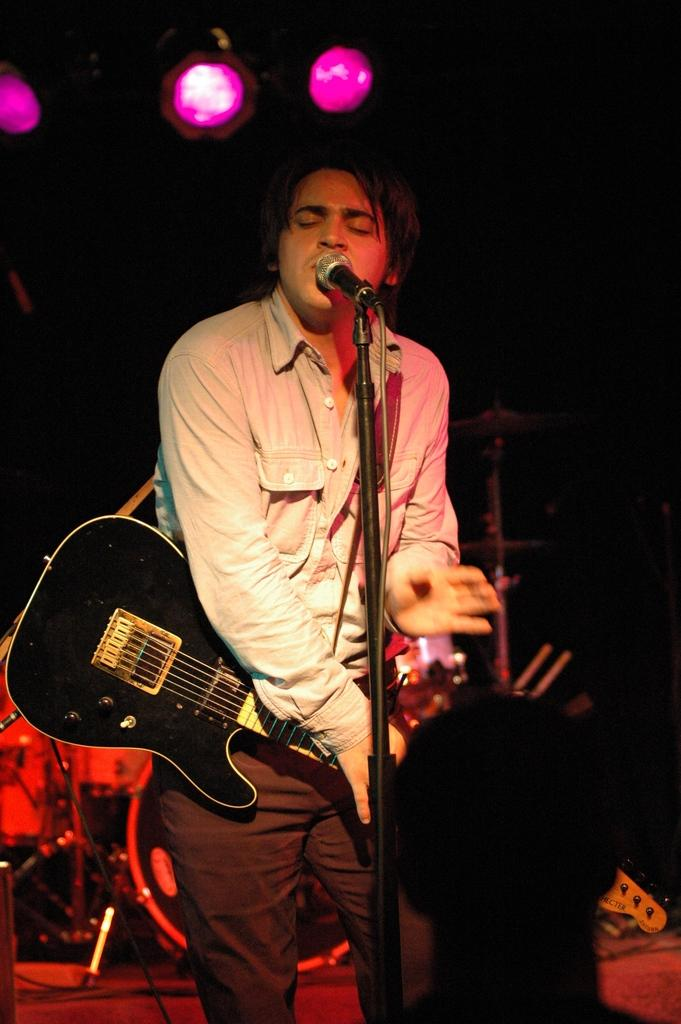What is the main subject of the image? There is a person in the image. What is the person doing in the image? The person is standing and holding a guitar. What other object is present in the image? There is a microphone in the image. What type of plastic detail can be seen on the doll in the image? There is no doll present in the image, so there are no plastic details to observe. 